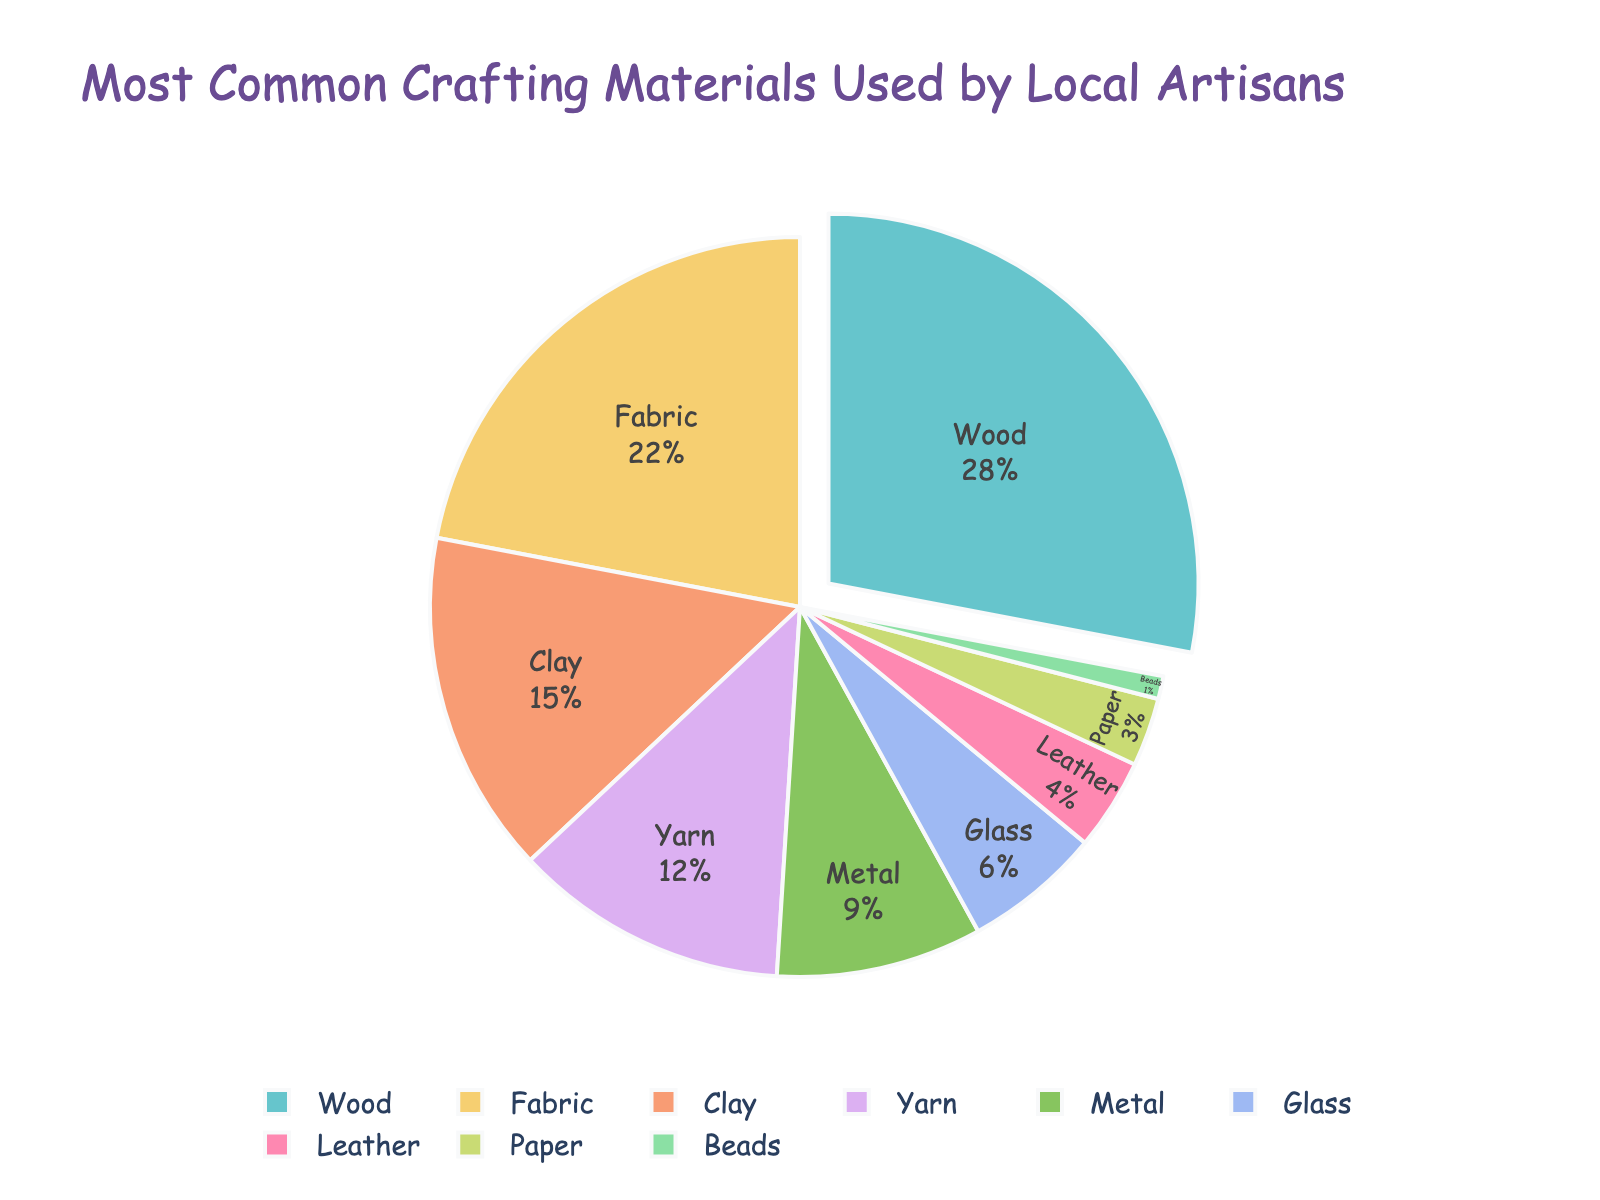Which material is used the most by local artisans? According to the pie chart, the material with the largest percentage is used the most. Wood has the largest slice, representing 28%.
Answer: Wood What is the total percentage of materials that are used less than 10%? Combine the percentages of materials with less than 10% usage: Metal (9), Glass (6), Leather (4), Paper (3), Beads (1). Summing these values: 9 + 6 + 4 + 3 + 1 = 23.
Answer: 23% How much more popular is Fabric compared to Yarn? The pie chart shows Fabric is 22% and Yarn is 12%. Subtracting the percentages gives: 22 - 12 = 10.
Answer: 10% Which material is the least used by local artisans? The material with the smallest slice represents the least usage. Beads have the smallest percentage, which is 1%.
Answer: Beads Are there more materials that use 5% or less or those that use 15% or more? Materials with 5% or less: Leather (4), Paper (3), Beads (1) - totaling 3 materials. Materials with 15% or more: Wood (28), Fabric (22), Clay (15) - totaling 3 materials. Since both groups have equal counts, the answer is equal.
Answer: Equal What is the sum of the percentages of the top three materials? The top three materials are Wood (28%), Fabric (22%), and Clay (15%). Summing these values: 28 + 22 + 15 = 65.
Answer: 65% Which materials make up between 10% to 20% of the total usage? From the pie chart, the percentages between 10% to 20% are Yarn (12%) and Clay (15%).
Answer: Yarn and Clay What percentage of the materials are non-fabric based? Total percentage is 100%. Fabric-based material is Fabric (22%). Therefore, non-fabric based is 100 - 22 = 78.
Answer: 78% Is Metal usage more than double the usage of Leather? The pie chart shows Metal is 9% and Leather is 4%. Double the usage of Leather is 4 * 2 = 8. Since Metal (9%) is greater than 8%, Metal usage is more than double Leather.
Answer: Yes 